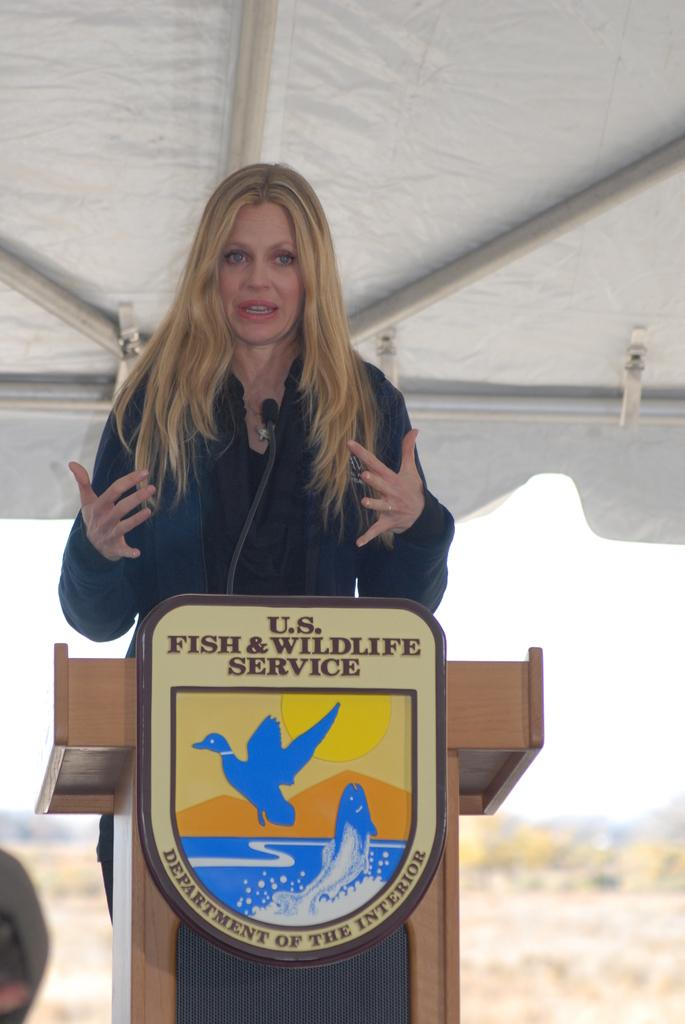Who is the main subject in the picture? There is a woman in the picture. What is the woman doing in the image? The woman is standing in front of a podium. Where is the podium located in the image? The podium is in the middle of the picture. Can you describe the background of the image? The background of the image is blurred. What type of scarf is the woman wearing in the image? There is no scarf visible in the image; the woman is not wearing one. How does the town look in the image? There is no town present in the image; it only features a woman standing in front of a podium. 